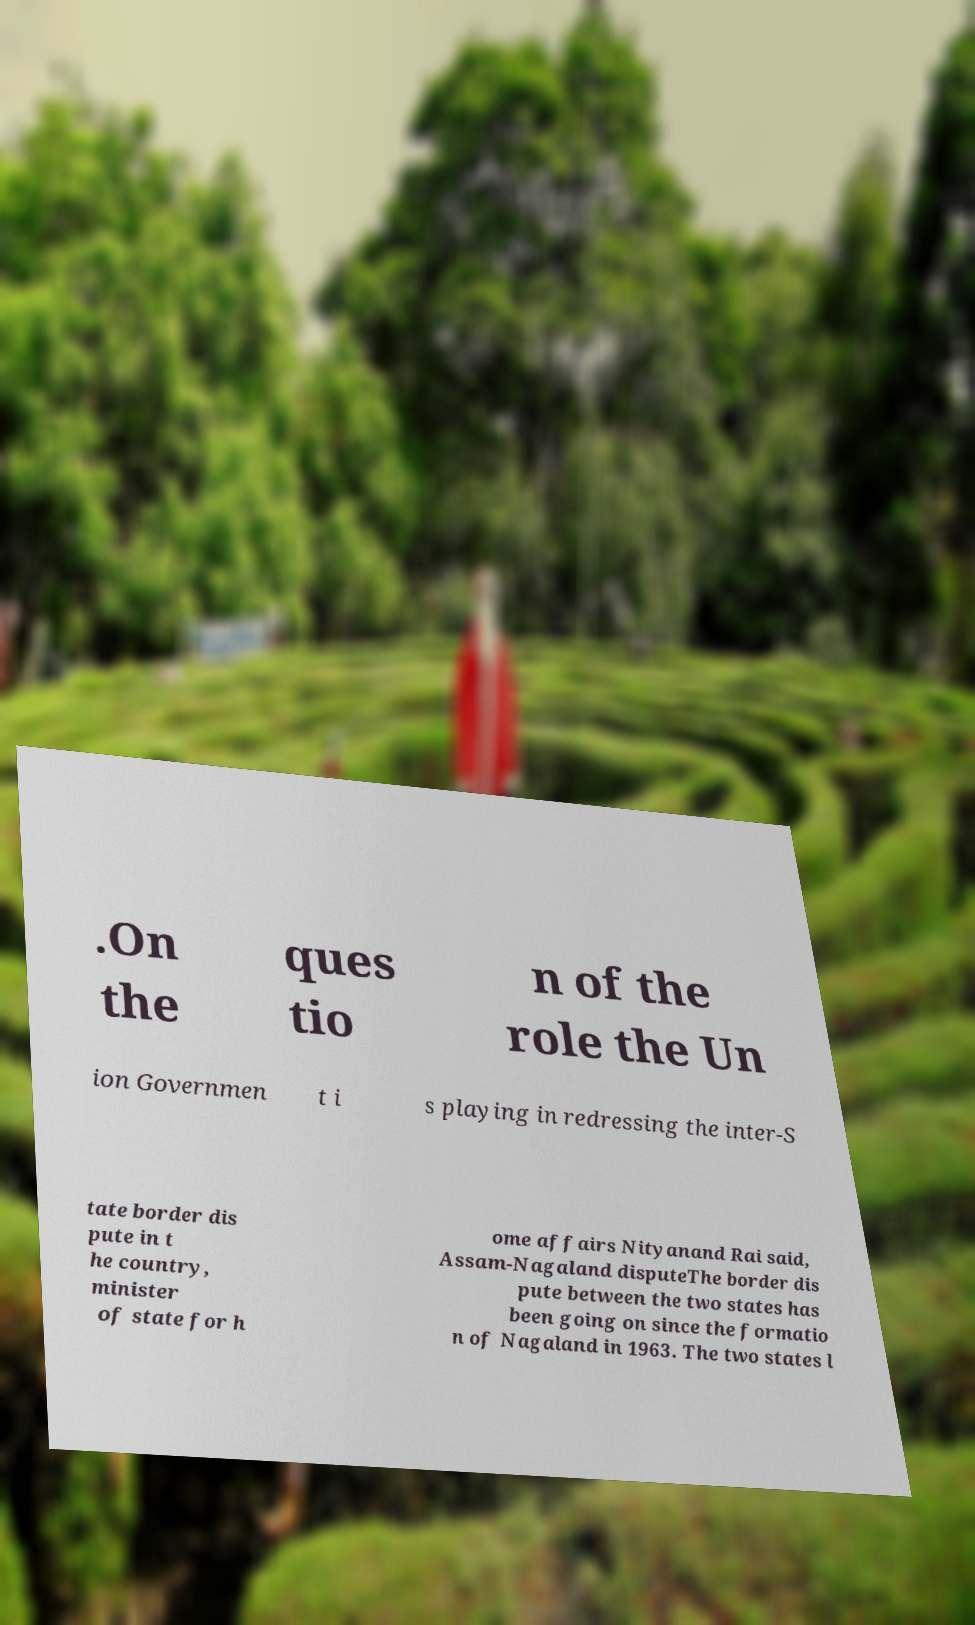Can you read and provide the text displayed in the image?This photo seems to have some interesting text. Can you extract and type it out for me? .On the ques tio n of the role the Un ion Governmen t i s playing in redressing the inter-S tate border dis pute in t he country, minister of state for h ome affairs Nityanand Rai said, Assam-Nagaland disputeThe border dis pute between the two states has been going on since the formatio n of Nagaland in 1963. The two states l 